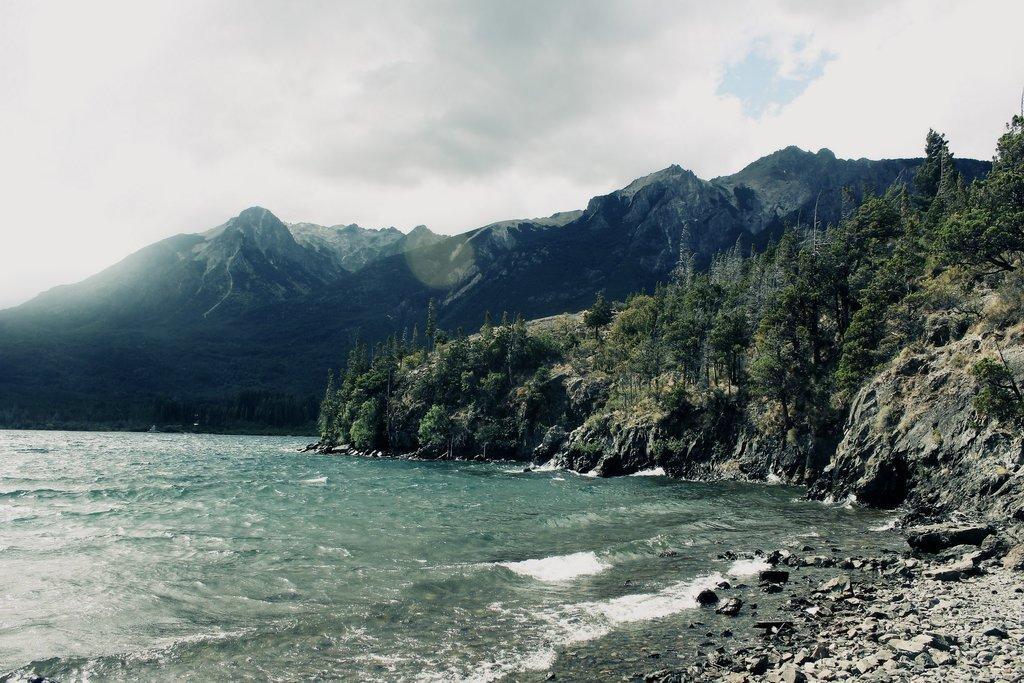Describe this image in one or two sentences. In this image, we can see some water. There are a few trees. We can see some hills and rocks. We can see the sky with clouds. 